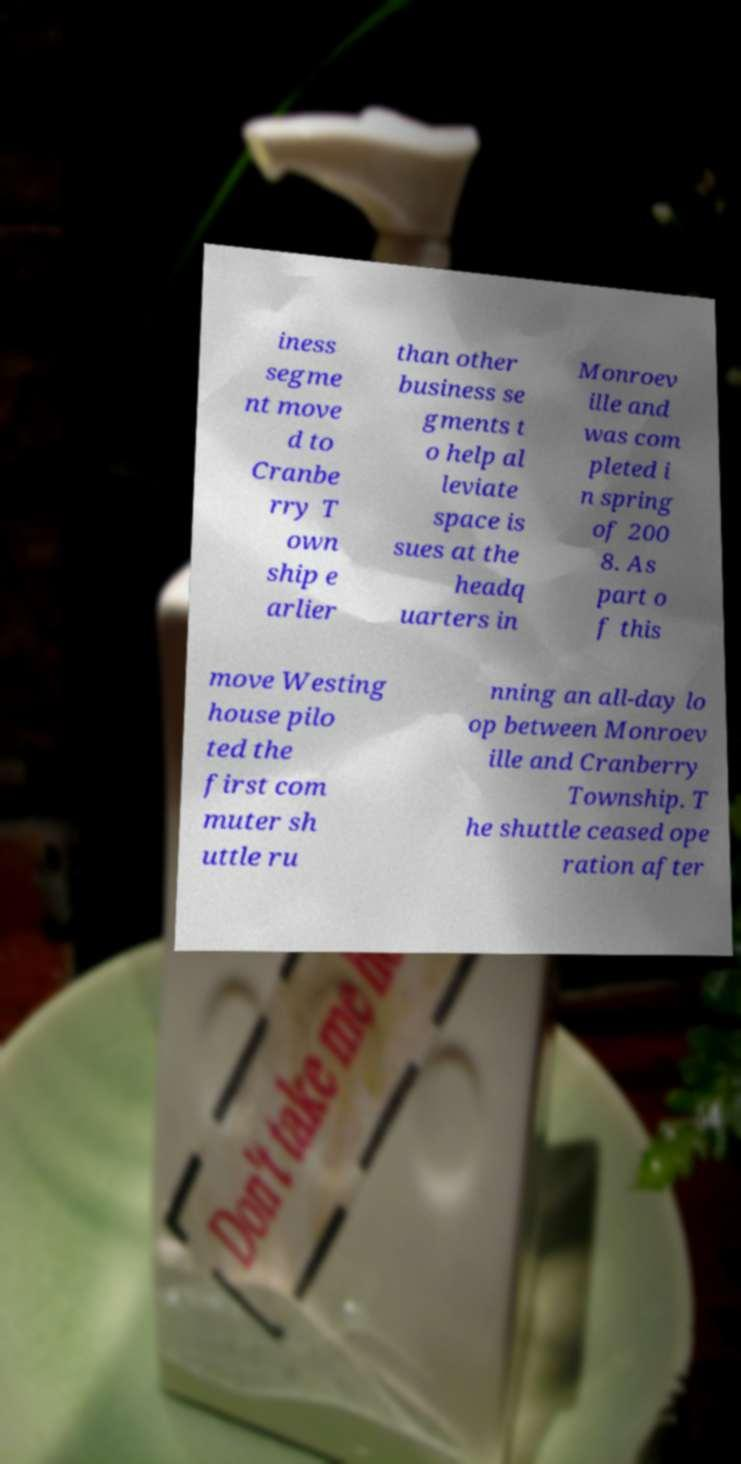Please identify and transcribe the text found in this image. iness segme nt move d to Cranbe rry T own ship e arlier than other business se gments t o help al leviate space is sues at the headq uarters in Monroev ille and was com pleted i n spring of 200 8. As part o f this move Westing house pilo ted the first com muter sh uttle ru nning an all-day lo op between Monroev ille and Cranberry Township. T he shuttle ceased ope ration after 